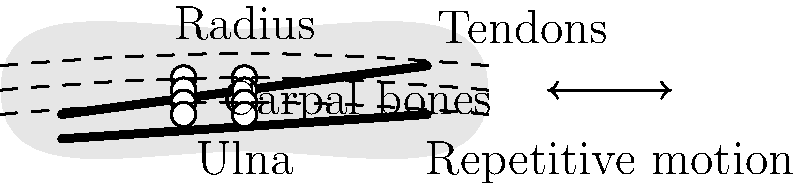As a DJ who frequently uses turntables, you're concerned about the impact of repetitive wrist motions on your joint health. Based on the wrist anatomy diagram, which structure is most likely to be affected by the continuous back-and-forth movements involved in scratching and mixing, potentially leading to inflammation and pain? To answer this question, let's analyze the wrist anatomy and the motion involved in using turntables:

1. The wrist consists of several structures:
   - Bones: Radius, ulna, and carpal bones
   - Soft tissues: Tendons, ligaments, and muscles

2. The repetitive motion in DJing involves:
   - Back-and-forth movements of the wrist
   - Rapid changes in direction
   - Prolonged periods of use

3. Impact on different structures:
   - Bones: Generally stable and less affected by repetitive motion
   - Carpal bones: May experience some stress but are designed for mobility
   - Tendons: Subjected to repeated stretching and contracting

4. Tendons are the most likely to be affected because:
   - They connect muscles to bones and facilitate movement
   - Repetitive motion can cause friction and microtrauma
   - Overuse can lead to inflammation (tendinitis) or degeneration (tendinosis)

5. In the diagram, tendons are represented by dashed lines running through the wrist

6. The condition resulting from this repetitive stress is often called "DJ's wrist" or "turntablist's wrist," which is a form of repetitive strain injury (RSI)

Therefore, the tendons are the structures most likely to be affected by the continuous back-and-forth movements involved in scratching and mixing on turntables.
Answer: Tendons 